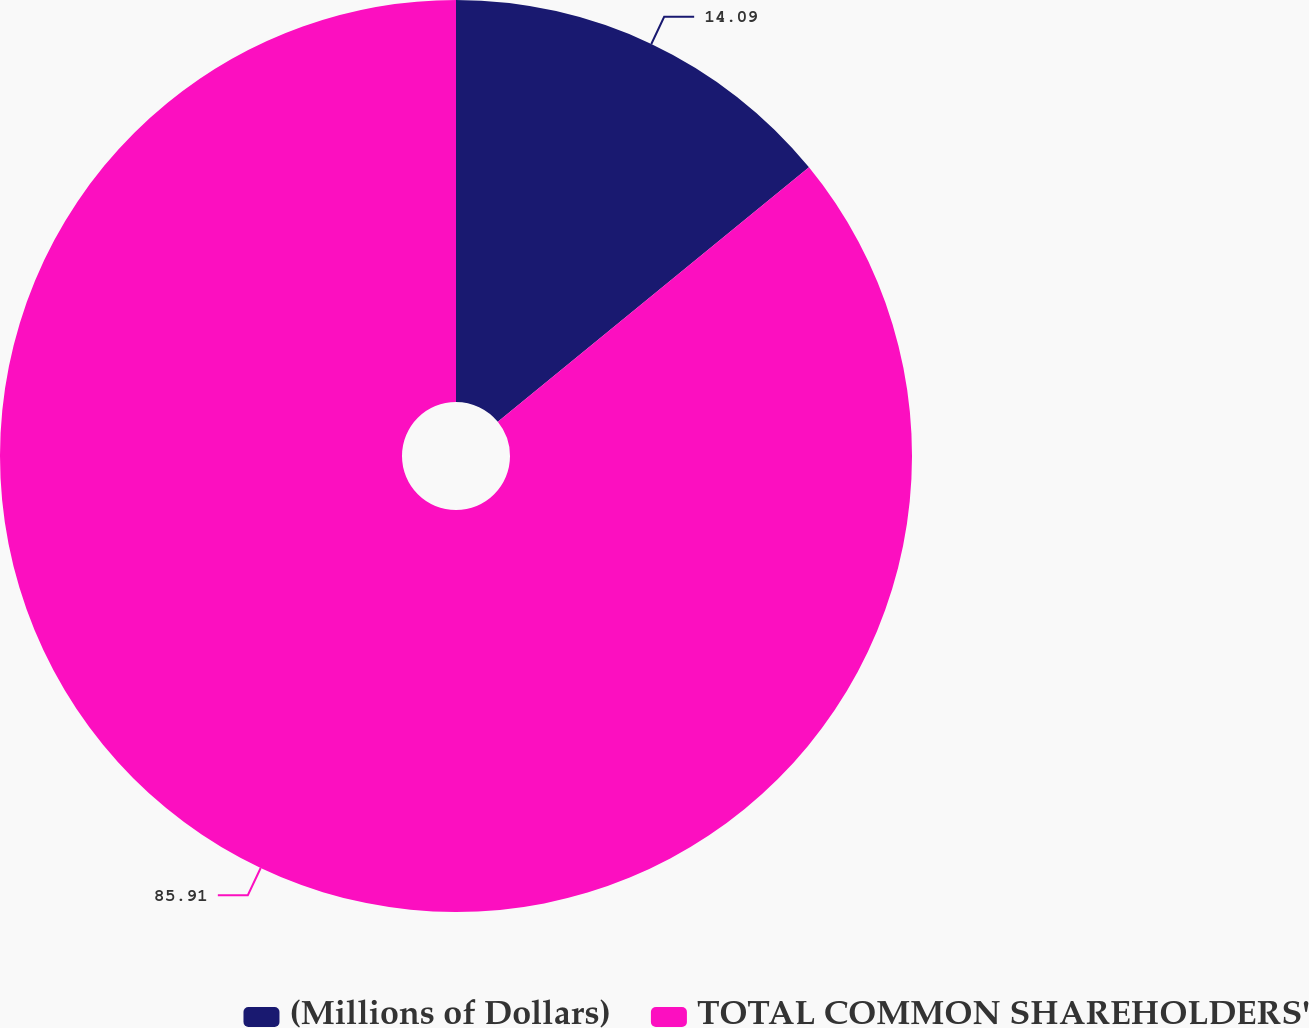Convert chart. <chart><loc_0><loc_0><loc_500><loc_500><pie_chart><fcel>(Millions of Dollars)<fcel>TOTAL COMMON SHAREHOLDERS'<nl><fcel>14.09%<fcel>85.91%<nl></chart> 